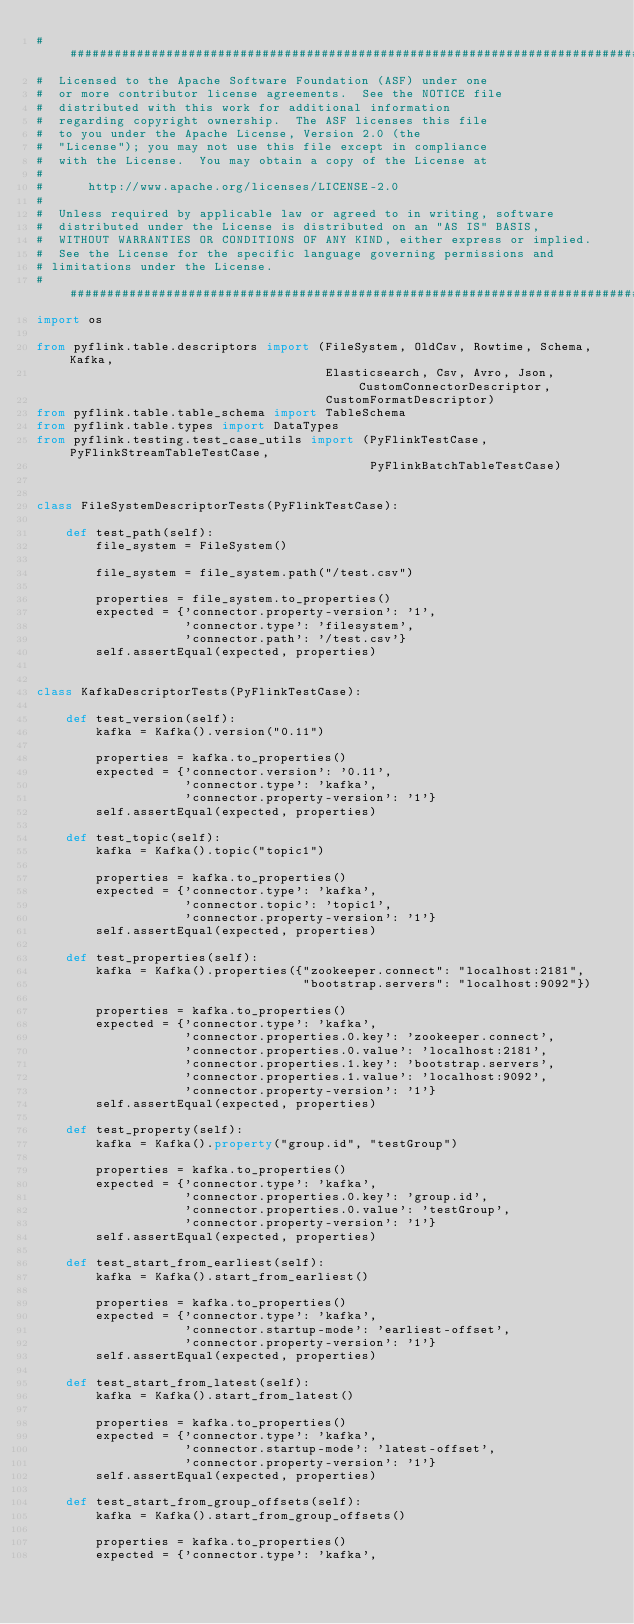Convert code to text. <code><loc_0><loc_0><loc_500><loc_500><_Python_>################################################################################
#  Licensed to the Apache Software Foundation (ASF) under one
#  or more contributor license agreements.  See the NOTICE file
#  distributed with this work for additional information
#  regarding copyright ownership.  The ASF licenses this file
#  to you under the Apache License, Version 2.0 (the
#  "License"); you may not use this file except in compliance
#  with the License.  You may obtain a copy of the License at
#
#      http://www.apache.org/licenses/LICENSE-2.0
#
#  Unless required by applicable law or agreed to in writing, software
#  distributed under the License is distributed on an "AS IS" BASIS,
#  WITHOUT WARRANTIES OR CONDITIONS OF ANY KIND, either express or implied.
#  See the License for the specific language governing permissions and
# limitations under the License.
################################################################################
import os

from pyflink.table.descriptors import (FileSystem, OldCsv, Rowtime, Schema, Kafka,
                                       Elasticsearch, Csv, Avro, Json, CustomConnectorDescriptor,
                                       CustomFormatDescriptor)
from pyflink.table.table_schema import TableSchema
from pyflink.table.types import DataTypes
from pyflink.testing.test_case_utils import (PyFlinkTestCase, PyFlinkStreamTableTestCase,
                                             PyFlinkBatchTableTestCase)


class FileSystemDescriptorTests(PyFlinkTestCase):

    def test_path(self):
        file_system = FileSystem()

        file_system = file_system.path("/test.csv")

        properties = file_system.to_properties()
        expected = {'connector.property-version': '1',
                    'connector.type': 'filesystem',
                    'connector.path': '/test.csv'}
        self.assertEqual(expected, properties)


class KafkaDescriptorTests(PyFlinkTestCase):

    def test_version(self):
        kafka = Kafka().version("0.11")

        properties = kafka.to_properties()
        expected = {'connector.version': '0.11',
                    'connector.type': 'kafka',
                    'connector.property-version': '1'}
        self.assertEqual(expected, properties)

    def test_topic(self):
        kafka = Kafka().topic("topic1")

        properties = kafka.to_properties()
        expected = {'connector.type': 'kafka',
                    'connector.topic': 'topic1',
                    'connector.property-version': '1'}
        self.assertEqual(expected, properties)

    def test_properties(self):
        kafka = Kafka().properties({"zookeeper.connect": "localhost:2181",
                                    "bootstrap.servers": "localhost:9092"})

        properties = kafka.to_properties()
        expected = {'connector.type': 'kafka',
                    'connector.properties.0.key': 'zookeeper.connect',
                    'connector.properties.0.value': 'localhost:2181',
                    'connector.properties.1.key': 'bootstrap.servers',
                    'connector.properties.1.value': 'localhost:9092',
                    'connector.property-version': '1'}
        self.assertEqual(expected, properties)

    def test_property(self):
        kafka = Kafka().property("group.id", "testGroup")

        properties = kafka.to_properties()
        expected = {'connector.type': 'kafka',
                    'connector.properties.0.key': 'group.id',
                    'connector.properties.0.value': 'testGroup',
                    'connector.property-version': '1'}
        self.assertEqual(expected, properties)

    def test_start_from_earliest(self):
        kafka = Kafka().start_from_earliest()

        properties = kafka.to_properties()
        expected = {'connector.type': 'kafka',
                    'connector.startup-mode': 'earliest-offset',
                    'connector.property-version': '1'}
        self.assertEqual(expected, properties)

    def test_start_from_latest(self):
        kafka = Kafka().start_from_latest()

        properties = kafka.to_properties()
        expected = {'connector.type': 'kafka',
                    'connector.startup-mode': 'latest-offset',
                    'connector.property-version': '1'}
        self.assertEqual(expected, properties)

    def test_start_from_group_offsets(self):
        kafka = Kafka().start_from_group_offsets()

        properties = kafka.to_properties()
        expected = {'connector.type': 'kafka',</code> 